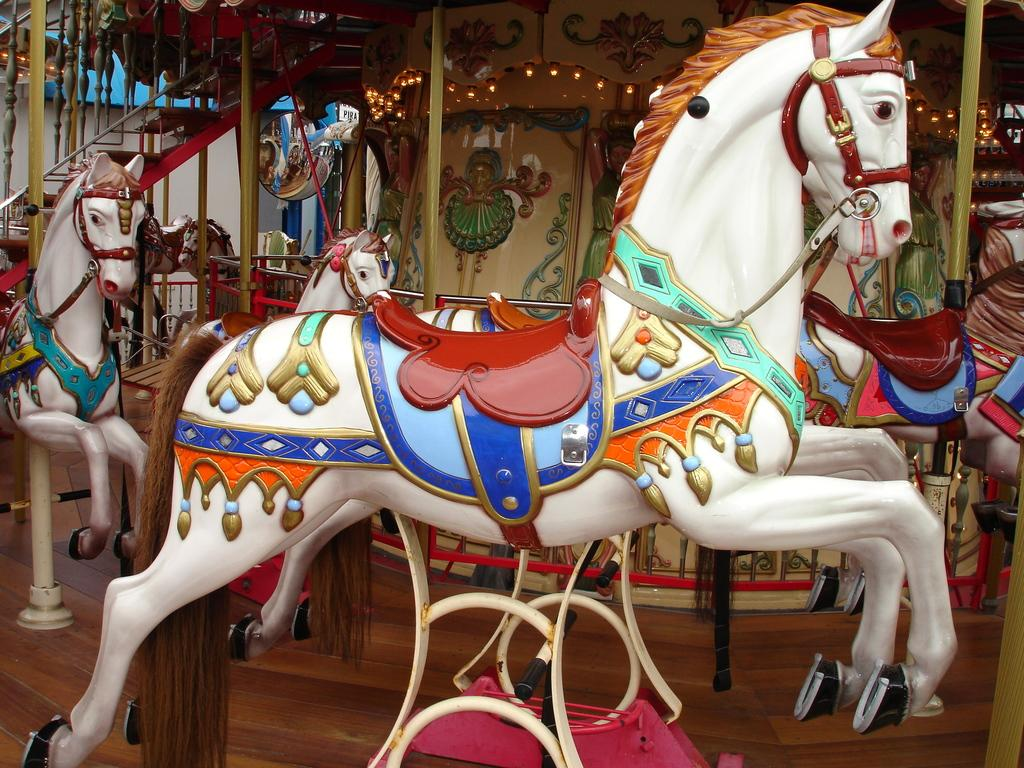What type of toys are present in the image? There are white color horse toys in the image. Can you describe any other objects in the image? There are other objects in the background of the image, but their specific details are not mentioned in the provided facts. What type of butter is being used to play with the horse toys in the image? There is no butter present in the image, and the horse toys are likely toys and not real horses. 